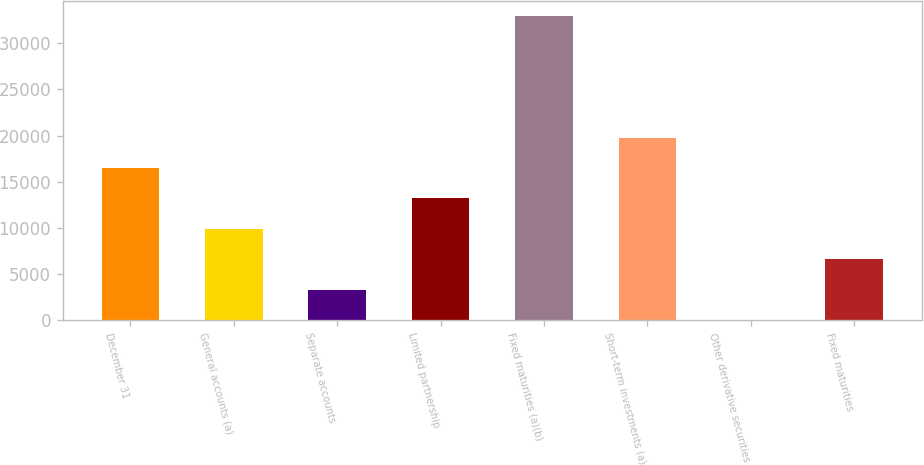Convert chart. <chart><loc_0><loc_0><loc_500><loc_500><bar_chart><fcel>December 31<fcel>General accounts (a)<fcel>Separate accounts<fcel>Limited partnership<fcel>Fixed maturities (a)(b)<fcel>Short-term investments (a)<fcel>Other derivative securities<fcel>Fixed maturities<nl><fcel>16484.5<fcel>9892.17<fcel>3299.79<fcel>13188.4<fcel>32965.5<fcel>19780.7<fcel>3.6<fcel>6595.98<nl></chart> 